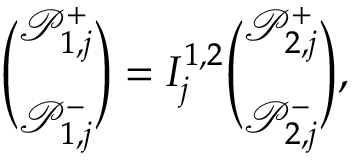<formula> <loc_0><loc_0><loc_500><loc_500>\binom { \mathcal { P } _ { 1 , j } ^ { + } } { \mathcal { P } _ { 1 , j } ^ { - } } = I _ { j } ^ { 1 , 2 } \binom { \mathcal { P } _ { 2 , j } ^ { + } } { \mathcal { P } _ { 2 , j } ^ { - } } ,</formula> 